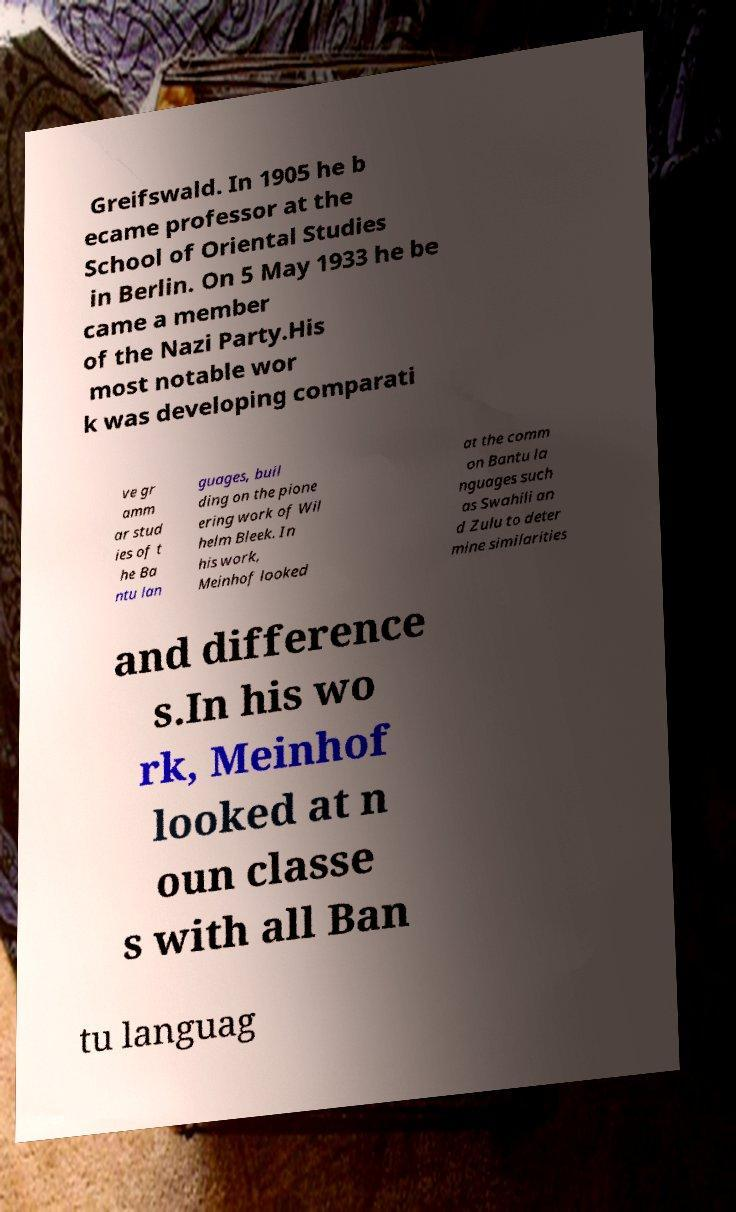For documentation purposes, I need the text within this image transcribed. Could you provide that? Greifswald. In 1905 he b ecame professor at the School of Oriental Studies in Berlin. On 5 May 1933 he be came a member of the Nazi Party.His most notable wor k was developing comparati ve gr amm ar stud ies of t he Ba ntu lan guages, buil ding on the pione ering work of Wil helm Bleek. In his work, Meinhof looked at the comm on Bantu la nguages such as Swahili an d Zulu to deter mine similarities and difference s.In his wo rk, Meinhof looked at n oun classe s with all Ban tu languag 